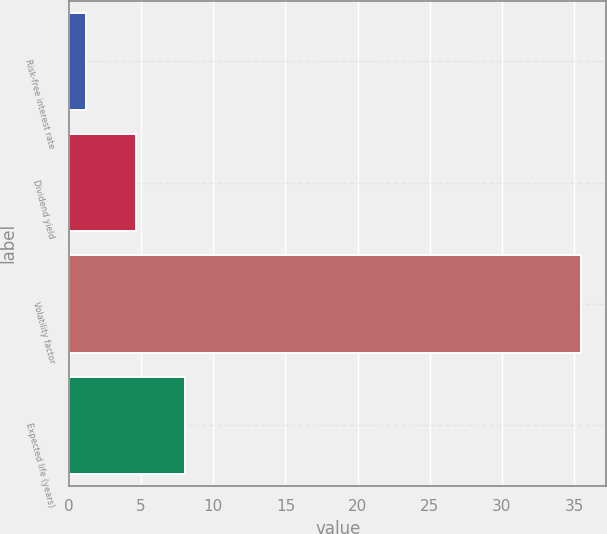Convert chart. <chart><loc_0><loc_0><loc_500><loc_500><bar_chart><fcel>Risk-free interest rate<fcel>Dividend yield<fcel>Volatility factor<fcel>Expected life (years)<nl><fcel>1.18<fcel>4.61<fcel>35.47<fcel>8.04<nl></chart> 